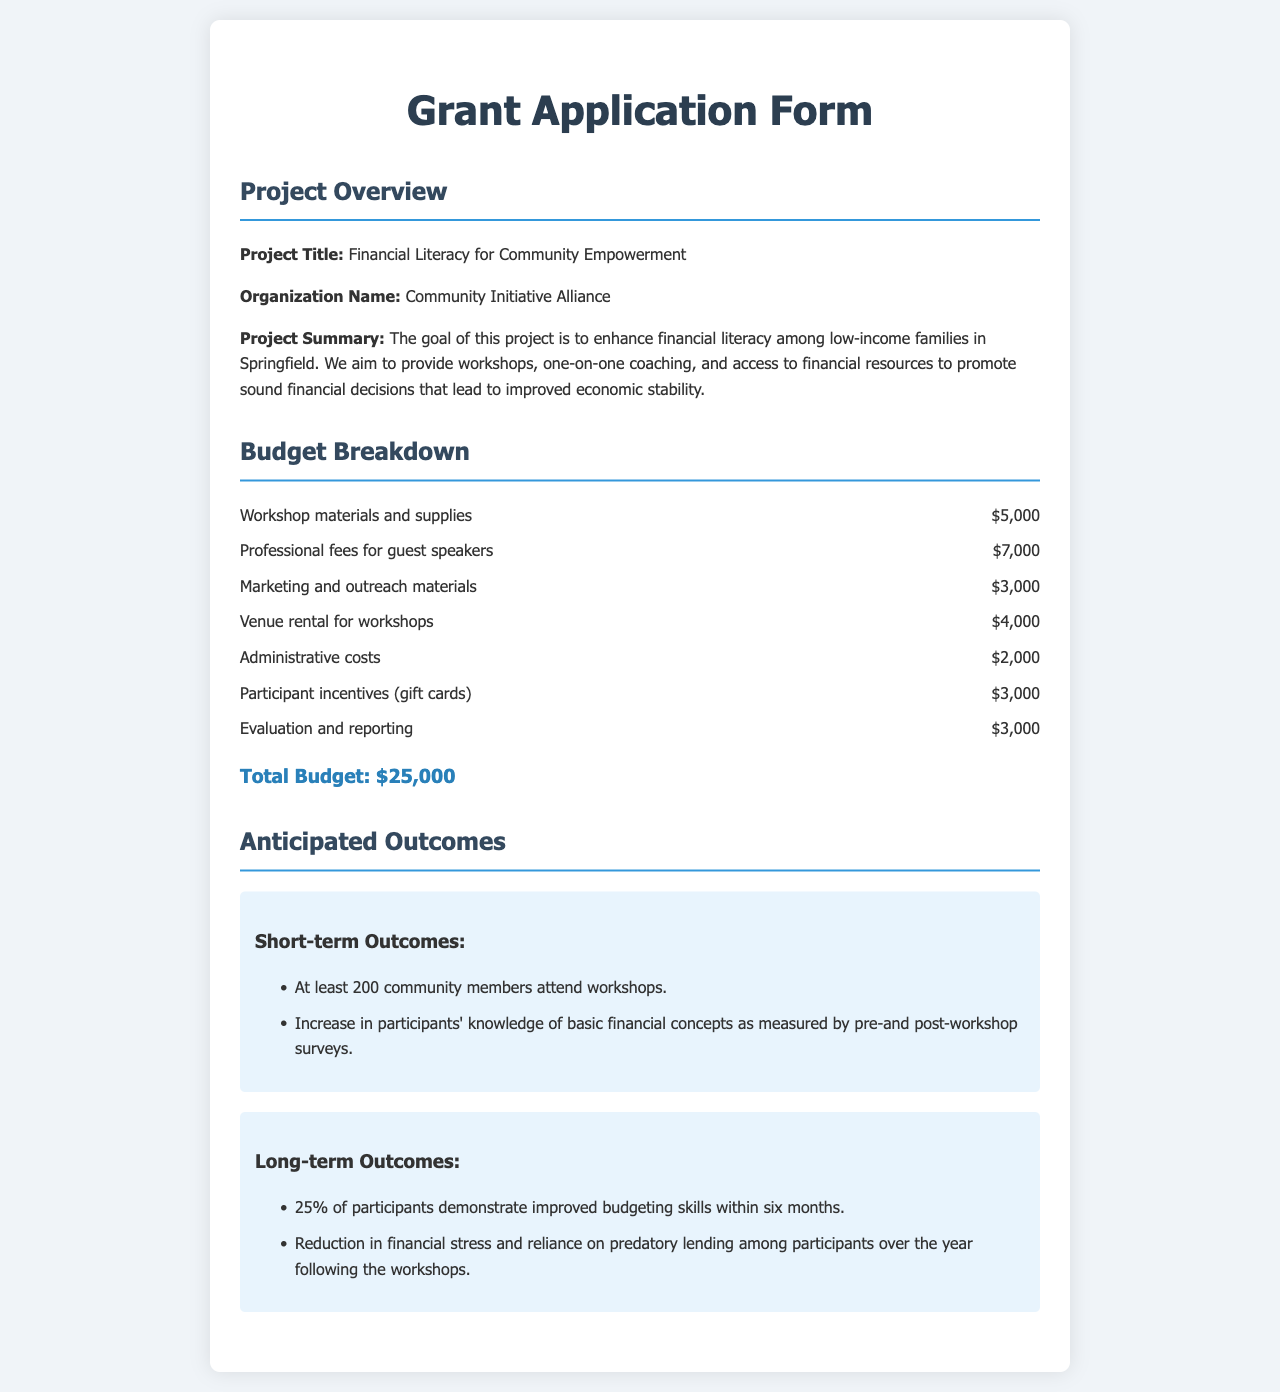What is the project title? The project title is listed in the document under Project Overview.
Answer: Financial Literacy for Community Empowerment What is the total budget for the project? The total budget is summarized at the end of the Budget Breakdown section.
Answer: $25,000 How many community members are expected to attend the workshops? This number is mentioned in the anticipated short-term outcomes section.
Answer: At least 200 What percentage of participants is expected to improve their budgeting skills? This percentage is stated among the long-term outcomes.
Answer: 25% What organization is applying for the grant? The organization name is provided in the Project Overview section.
Answer: Community Initiative Alliance What are the administrative costs included in the budget? Administrative costs are specified in the Budget Breakdown section.
Answer: $2,000 What type of coaching will be provided as part of the project? The project summary outlines the type of support to be given.
Answer: One-on-one coaching What is the expected reduction in financial stress for participants? The anticipated long-term outcome mentions a specific effect on financial stress among participants.
Answer: Reduction in financial stress and reliance on predatory lending What materials are budgeted for marketing and outreach? This detail is found in the Budget Breakdown under a specific item.
Answer: $3,000 What are the guest speaker fees for the project? The document specifies this amount in the budget section.
Answer: $7,000 